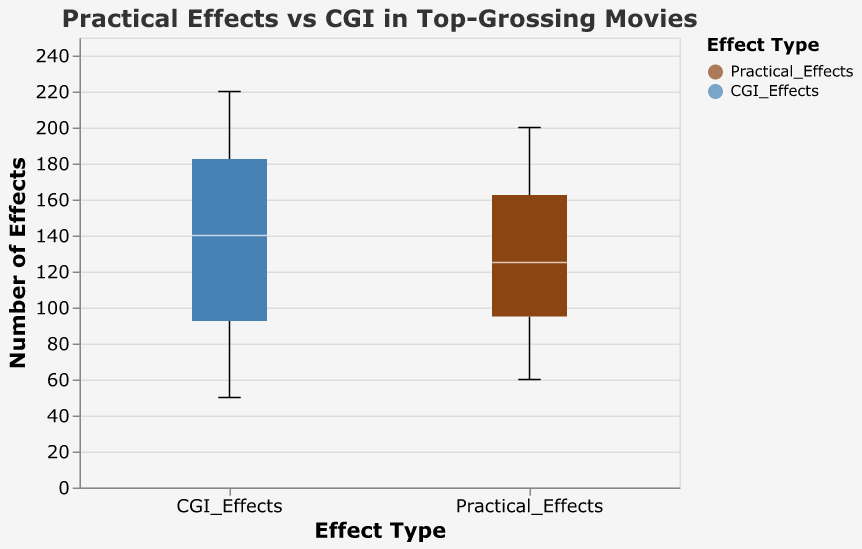What is the title of the figure? The title is located at the top of the figure and reads: "Practical Effects vs CGI in Top-Grossing Movies."
Answer: Practical Effects vs CGI in Top-Grossing Movies How many types of effects are shown in the figure? The figure shows two types of effects, which are listed on the x-axis: Practical Effects and CGI Effects.
Answer: Two What is the median number of Practical Effects? In a box plot, the median is typically marked by the line inside the box. The median number of Practical Effects can be observed from this line.
Answer: 120 Which effect type has the greater median value? Compare the lines inside the boxes for both Practical Effects and CGI Effects on the y-axis. The median of CGI Effects is higher than Practical Effects.
Answer: CGI Effects What is the range of the number of Practical Effects? The range is determined by the difference between the maximum and minimum values, shown by the top and bottom edges of the whiskers.
Answer: 60 to 200 What is the maximum number of CGI Effects used in any movie? The maximum value in a box plot is indicated by the top edge of the whisker for the respective category.
Answer: 220 What is the interquartile range (IQR) for Practical Effects? The IQR is the distance between the first quartile (bottom edge of the box) and the third quartile (top edge of the box). For Practical Effects, it can be observed from these edges.
Answer: 90 How does the variability (spread) of CGI Effects compare to Practical Effects? Variability can be assessed by comparing the lengths of the whiskers and the IQRs of the two categories. CGI Effects show a wider spread compared to Practical Effects.
Answer: CGI Effects have a greater variability Which movie has the highest number of Practical Effects? By referring to the specific data point outliers, we can identify which movie has the highest number of Practical Effects.
Answer: The Lord of the Rings: The Return of the King Based on the figure, is there an overall trend showing a preference for CGI over practical effects in top-grossing movies? By comparing the medians and ranges visually, we can infer that CGI Effects generally tend to have higher numbers compared to Practical Effects, suggesting a preference for CGI in top-grossing movies.
Answer: Yes, there is a trend showing a preference for CGI 